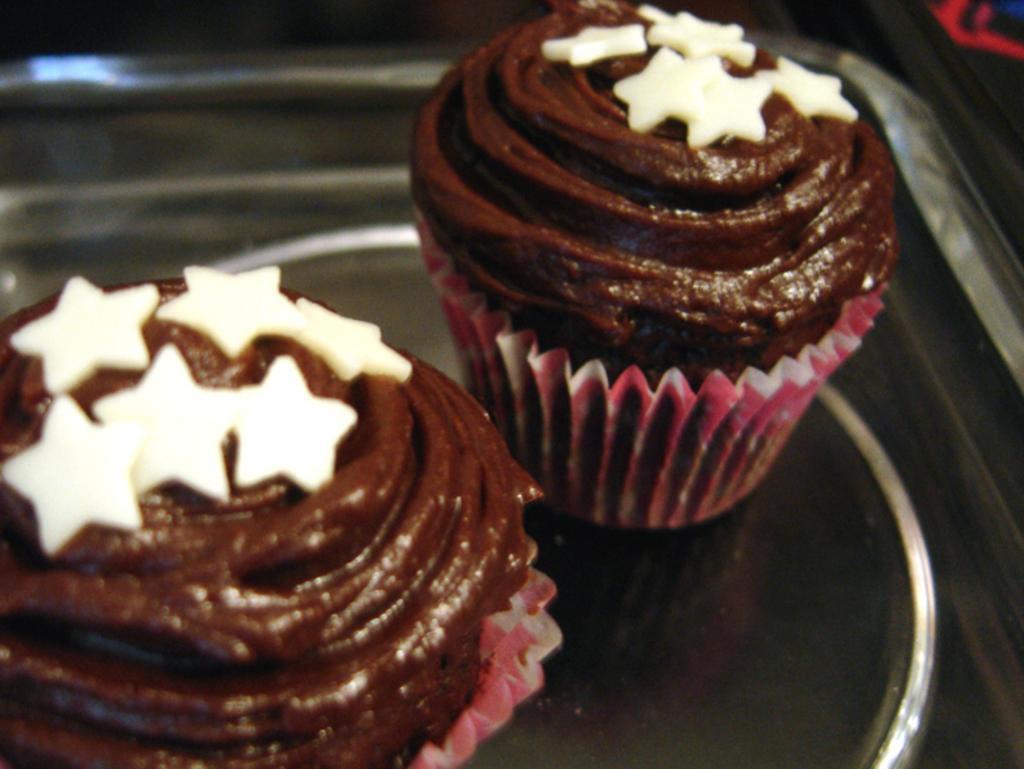Could you give a brief overview of what you see in this image? In this image I can see two cupcakes are placed on a tray. On the cupcakes, I can see brown color cream. 